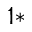Convert formula to latex. <formula><loc_0><loc_0><loc_500><loc_500>^ { 1 \ast }</formula> 